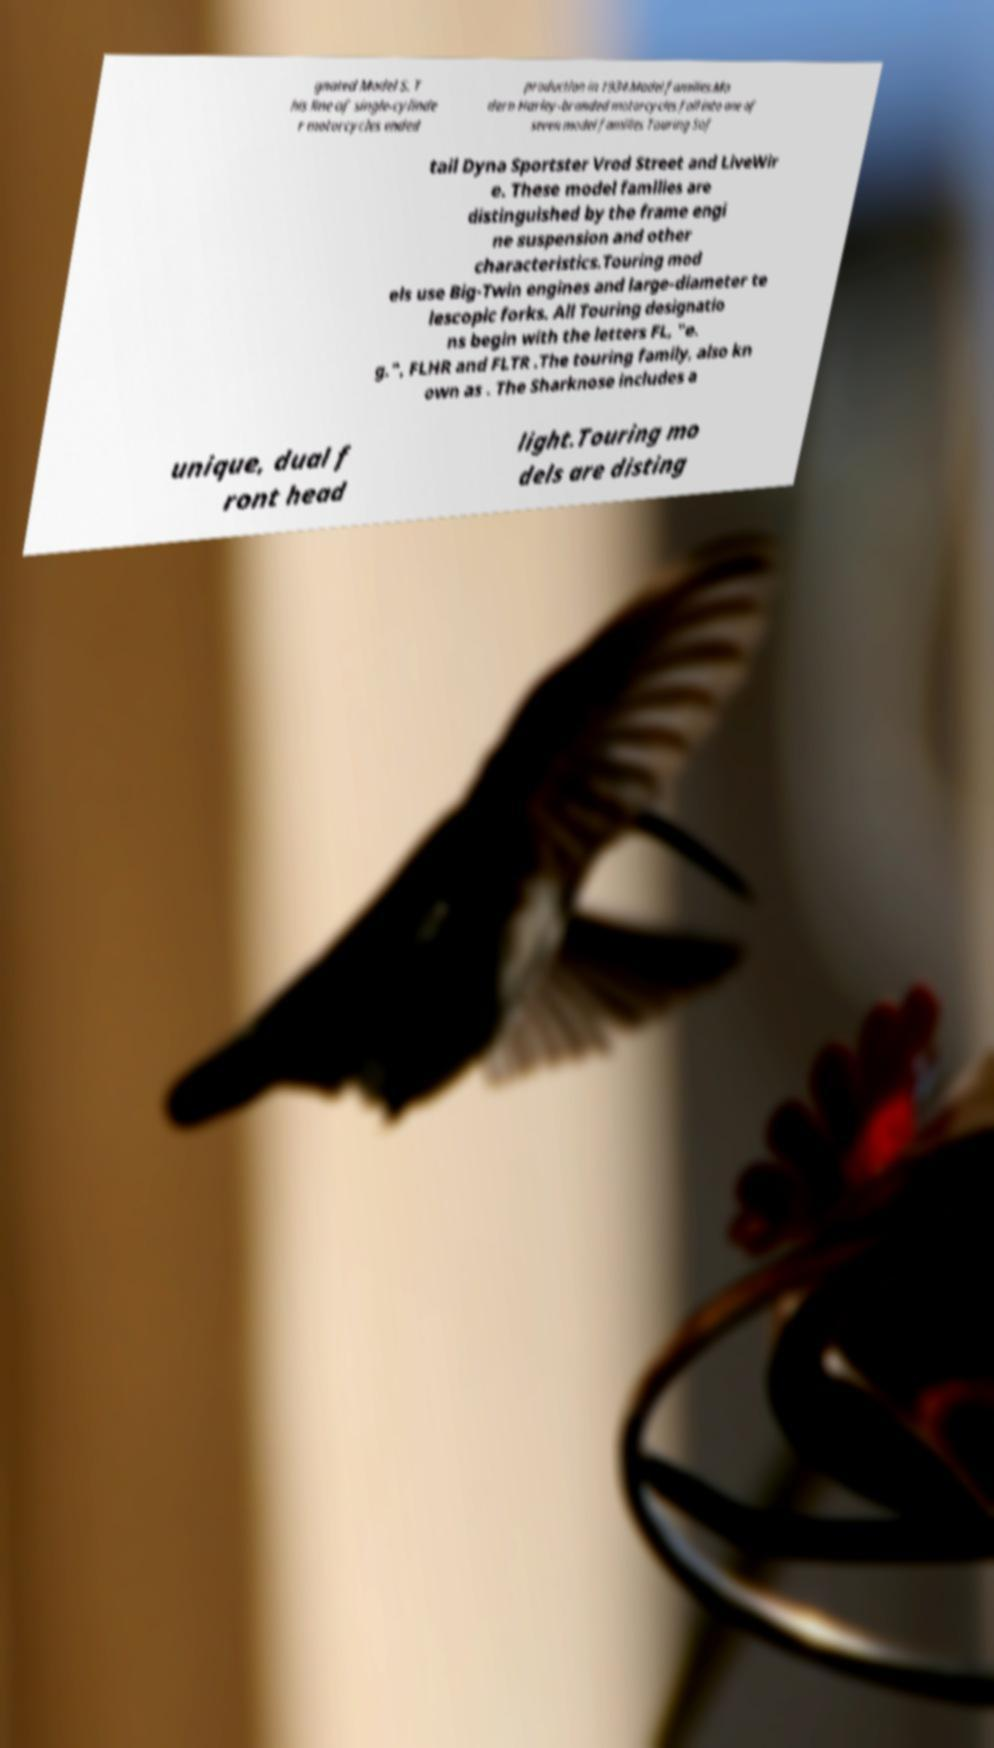Can you accurately transcribe the text from the provided image for me? gnated Model S. T his line of single-cylinde r motorcycles ended production in 1934.Model families.Mo dern Harley-branded motorcycles fall into one of seven model families Touring Sof tail Dyna Sportster Vrod Street and LiveWir e. These model families are distinguished by the frame engi ne suspension and other characteristics.Touring mod els use Big-Twin engines and large-diameter te lescopic forks. All Touring designatio ns begin with the letters FL, "e. g.", FLHR and FLTR .The touring family, also kn own as . The Sharknose includes a unique, dual f ront head light.Touring mo dels are disting 